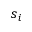Convert formula to latex. <formula><loc_0><loc_0><loc_500><loc_500>s _ { i }</formula> 